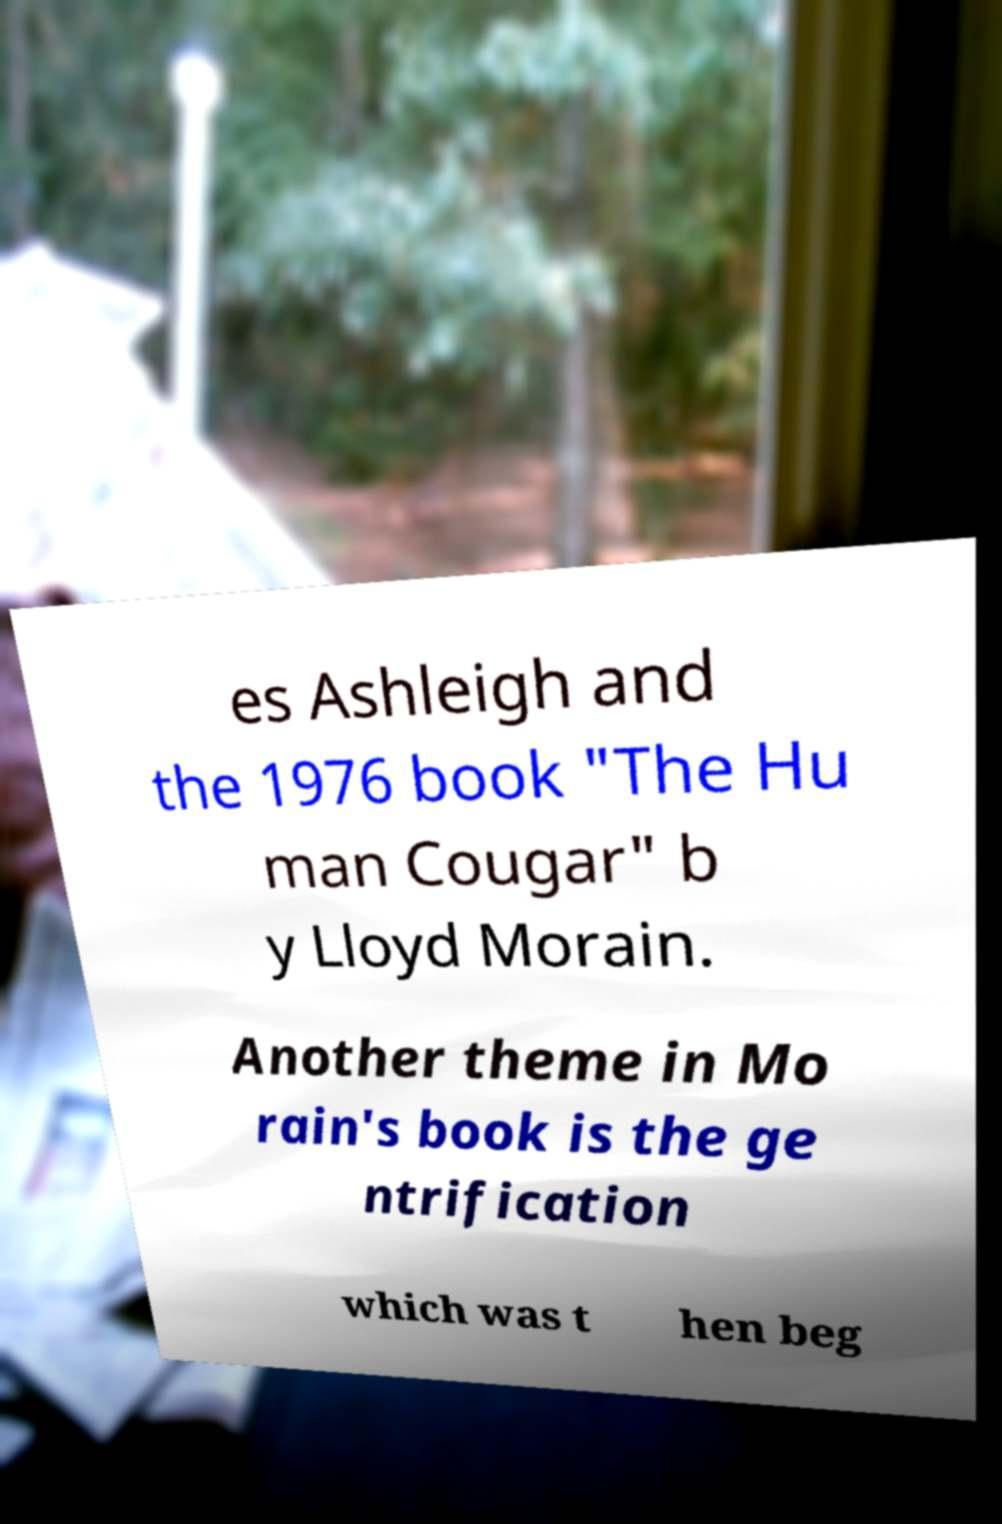I need the written content from this picture converted into text. Can you do that? es Ashleigh and the 1976 book "The Hu man Cougar" b y Lloyd Morain. Another theme in Mo rain's book is the ge ntrification which was t hen beg 